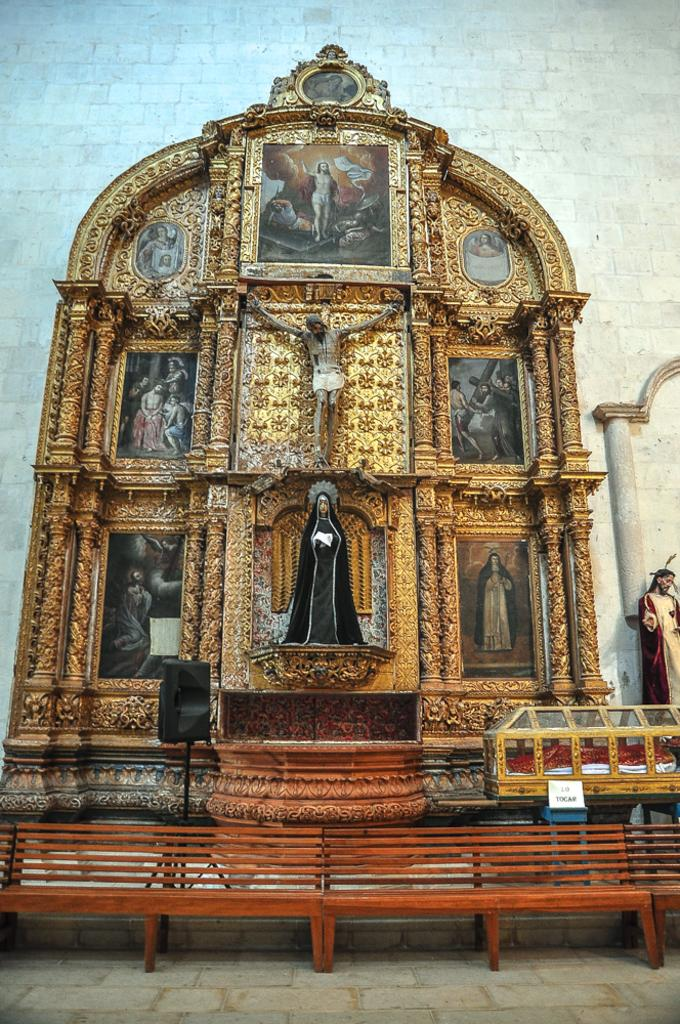What types of objects can be seen in the image? There are status and photo frames in the image. What type of furniture is present at the bottom of the image? There are benches at the bottom of the image. What is visible in the background of the image? There is a wall in the background of the image. What device is visible in the image for playing audio? There is a speaker visible in the image. What type of crib is visible in the image? There is no crib present in the image. What type of milk is being served in the photo frames? The photo frames do not contain milk; they are used for displaying images or artwork. 